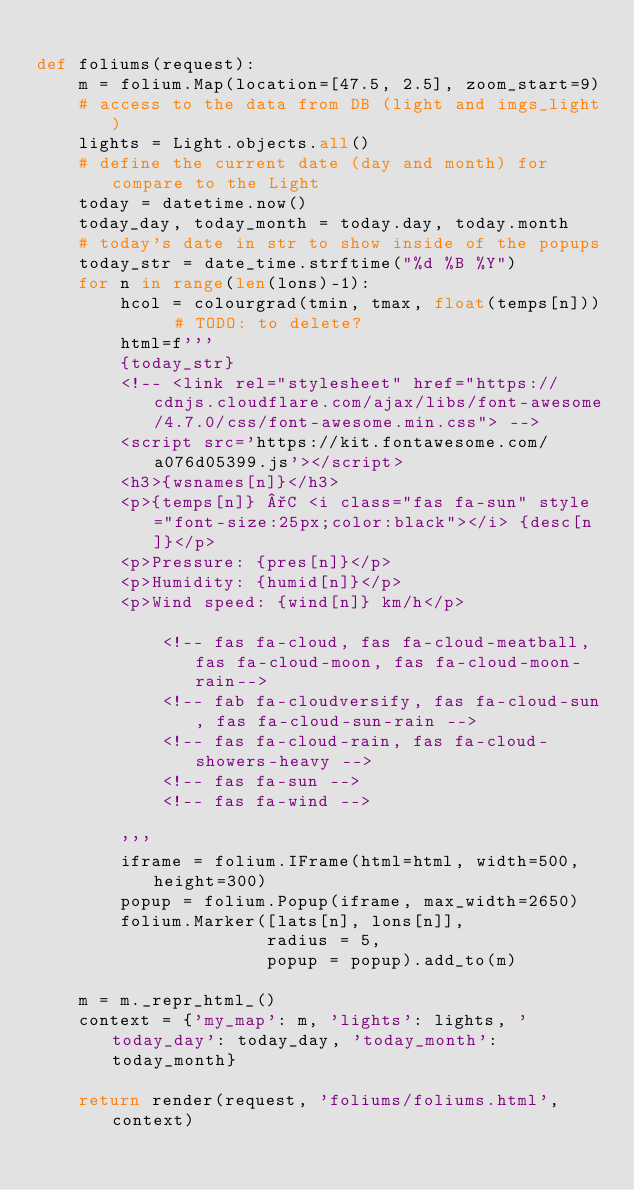<code> <loc_0><loc_0><loc_500><loc_500><_Python_>
def foliums(request):
    m = folium.Map(location=[47.5, 2.5], zoom_start=9)
    # access to the data from DB (light and imgs_light)
    lights = Light.objects.all()
    # define the current date (day and month) for compare to the Light
    today = datetime.now()
    today_day, today_month = today.day, today.month
    # today's date in str to show inside of the popups
    today_str = date_time.strftime("%d %B %Y")
    for n in range(len(lons)-1):
        hcol = colourgrad(tmin, tmax, float(temps[n]))  # TODO: to delete?
        html=f'''
        {today_str}
        <!-- <link rel="stylesheet" href="https://cdnjs.cloudflare.com/ajax/libs/font-awesome/4.7.0/css/font-awesome.min.css"> -->
        <script src='https://kit.fontawesome.com/a076d05399.js'></script>
        <h3>{wsnames[n]}</h3>
        <p>{temps[n]} °C <i class="fas fa-sun" style="font-size:25px;color:black"></i> {desc[n]}</p>
        <p>Pressure: {pres[n]}</p>
        <p>Humidity: {humid[n]}</p>
        <p>Wind speed: {wind[n]} km/h</p>

            <!-- fas fa-cloud, fas fa-cloud-meatball, fas fa-cloud-moon, fas fa-cloud-moon-rain-->
            <!-- fab fa-cloudversify, fas fa-cloud-sun, fas fa-cloud-sun-rain -->
            <!-- fas fa-cloud-rain, fas fa-cloud-showers-heavy -->
            <!-- fas fa-sun -->
            <!-- fas fa-wind -->

        '''
        iframe = folium.IFrame(html=html, width=500, height=300)
        popup = folium.Popup(iframe, max_width=2650)
        folium.Marker([lats[n], lons[n]],
                      radius = 5,
                      popup = popup).add_to(m)

    m = m._repr_html_()
    context = {'my_map': m, 'lights': lights, 'today_day': today_day, 'today_month': today_month}

    return render(request, 'foliums/foliums.html', context)
</code> 